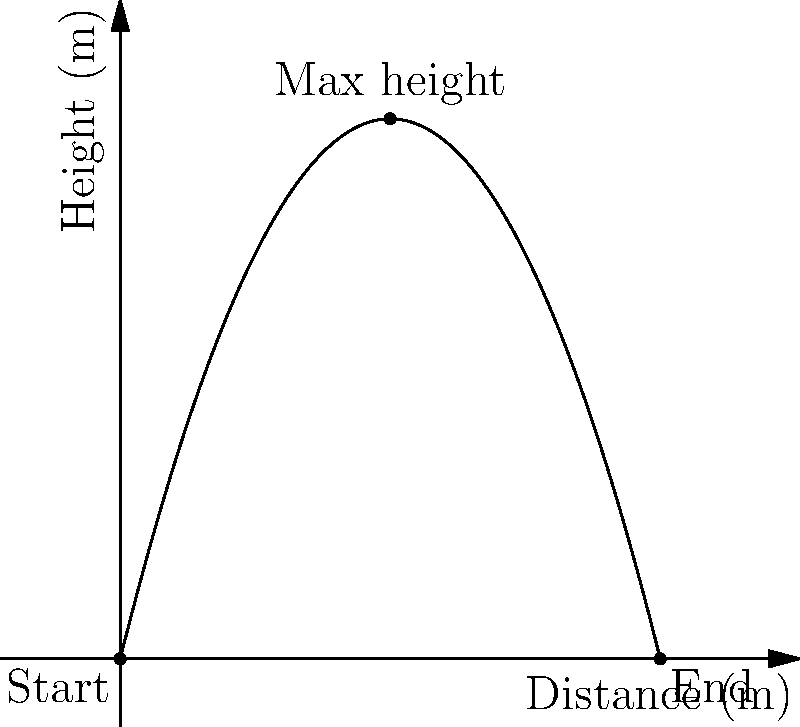As a jumping instructor, you're analyzing the trajectory of a long jump. The path of the jumper can be modeled by the polynomial function $h(x) = -0.5x^2 + 4x$, where $h$ is the height in meters and $x$ is the horizontal distance in meters. What is the total horizontal distance covered by the jumper? To find the total horizontal distance, we need to determine where the jumper lands, which is when the height becomes zero again. Let's solve this step-by-step:

1) The function is $h(x) = -0.5x^2 + 4x$

2) We need to find where $h(x) = 0$:
   $0 = -0.5x^2 + 4x$

3) Rearrange the equation:
   $0.5x^2 - 4x = 0$

4) Factor out the common factor:
   $x(0.5x - 4) = 0$

5) Use the zero product property. $x = 0$ or $0.5x - 4 = 0$

6) Solve $0.5x - 4 = 0$:
   $0.5x = 4$
   $x = 8$

7) $x = 0$ represents the starting point, and $x = 8$ represents the landing point.

Therefore, the total horizontal distance covered by the jumper is 8 meters.
Answer: 8 meters 